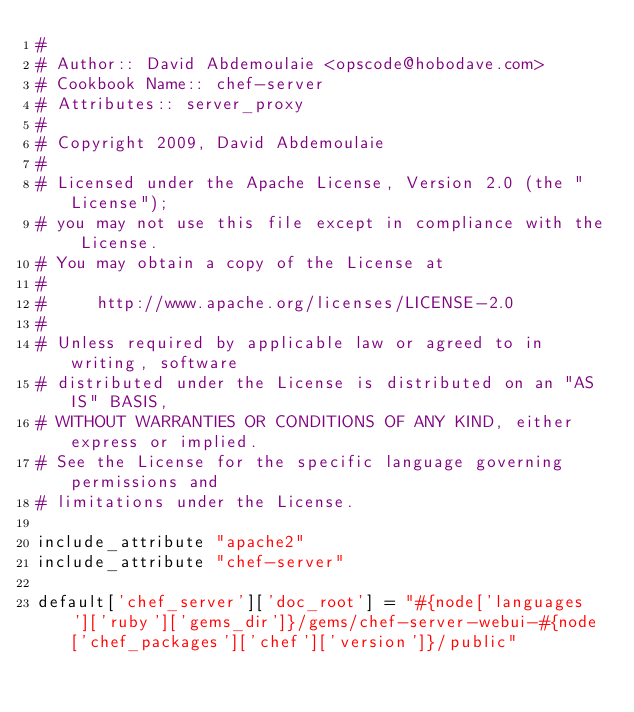<code> <loc_0><loc_0><loc_500><loc_500><_Ruby_>#
# Author:: David Abdemoulaie <opscode@hobodave.com>
# Cookbook Name:: chef-server
# Attributes:: server_proxy
#
# Copyright 2009, David Abdemoulaie
#
# Licensed under the Apache License, Version 2.0 (the "License");
# you may not use this file except in compliance with the License.
# You may obtain a copy of the License at
#
#     http://www.apache.org/licenses/LICENSE-2.0
#
# Unless required by applicable law or agreed to in writing, software
# distributed under the License is distributed on an "AS IS" BASIS,
# WITHOUT WARRANTIES OR CONDITIONS OF ANY KIND, either express or implied.
# See the License for the specific language governing permissions and
# limitations under the License.

include_attribute "apache2"
include_attribute "chef-server"

default['chef_server']['doc_root'] = "#{node['languages']['ruby']['gems_dir']}/gems/chef-server-webui-#{node['chef_packages']['chef']['version']}/public"</code> 